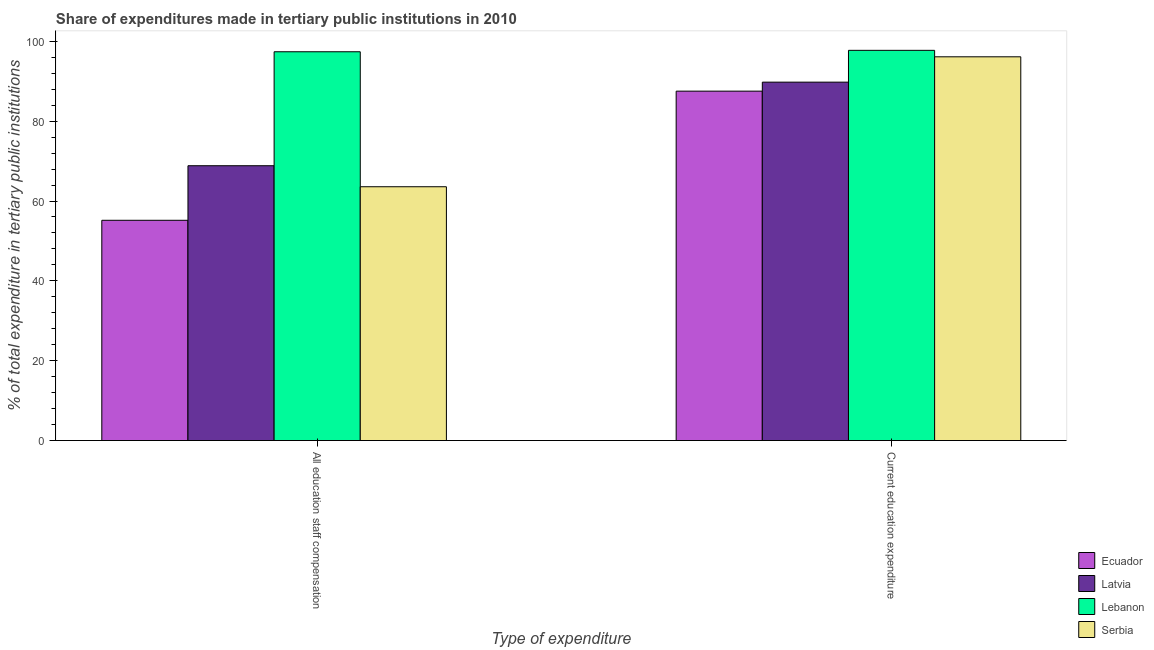How many different coloured bars are there?
Give a very brief answer. 4. How many groups of bars are there?
Your answer should be very brief. 2. How many bars are there on the 2nd tick from the left?
Give a very brief answer. 4. How many bars are there on the 1st tick from the right?
Ensure brevity in your answer.  4. What is the label of the 1st group of bars from the left?
Provide a short and direct response. All education staff compensation. What is the expenditure in staff compensation in Latvia?
Provide a succinct answer. 68.84. Across all countries, what is the maximum expenditure in staff compensation?
Your answer should be compact. 97.38. Across all countries, what is the minimum expenditure in education?
Your response must be concise. 87.52. In which country was the expenditure in staff compensation maximum?
Offer a very short reply. Lebanon. In which country was the expenditure in education minimum?
Keep it short and to the point. Ecuador. What is the total expenditure in staff compensation in the graph?
Your answer should be very brief. 284.96. What is the difference between the expenditure in education in Serbia and that in Lebanon?
Make the answer very short. -1.62. What is the difference between the expenditure in staff compensation in Lebanon and the expenditure in education in Ecuador?
Your answer should be very brief. 9.86. What is the average expenditure in education per country?
Offer a very short reply. 92.78. What is the difference between the expenditure in education and expenditure in staff compensation in Latvia?
Your response must be concise. 20.93. What is the ratio of the expenditure in staff compensation in Lebanon to that in Latvia?
Provide a short and direct response. 1.41. In how many countries, is the expenditure in staff compensation greater than the average expenditure in staff compensation taken over all countries?
Your answer should be very brief. 1. What does the 4th bar from the left in Current education expenditure represents?
Your answer should be very brief. Serbia. What does the 2nd bar from the right in Current education expenditure represents?
Your response must be concise. Lebanon. How many bars are there?
Provide a succinct answer. 8. Are all the bars in the graph horizontal?
Keep it short and to the point. No. What is the title of the graph?
Ensure brevity in your answer.  Share of expenditures made in tertiary public institutions in 2010. What is the label or title of the X-axis?
Provide a succinct answer. Type of expenditure. What is the label or title of the Y-axis?
Your answer should be compact. % of total expenditure in tertiary public institutions. What is the % of total expenditure in tertiary public institutions of Ecuador in All education staff compensation?
Ensure brevity in your answer.  55.17. What is the % of total expenditure in tertiary public institutions in Latvia in All education staff compensation?
Your answer should be compact. 68.84. What is the % of total expenditure in tertiary public institutions in Lebanon in All education staff compensation?
Offer a terse response. 97.38. What is the % of total expenditure in tertiary public institutions of Serbia in All education staff compensation?
Make the answer very short. 63.57. What is the % of total expenditure in tertiary public institutions of Ecuador in Current education expenditure?
Provide a succinct answer. 87.52. What is the % of total expenditure in tertiary public institutions in Latvia in Current education expenditure?
Your answer should be very brief. 89.77. What is the % of total expenditure in tertiary public institutions in Lebanon in Current education expenditure?
Give a very brief answer. 97.74. What is the % of total expenditure in tertiary public institutions in Serbia in Current education expenditure?
Offer a very short reply. 96.12. Across all Type of expenditure, what is the maximum % of total expenditure in tertiary public institutions of Ecuador?
Your answer should be very brief. 87.52. Across all Type of expenditure, what is the maximum % of total expenditure in tertiary public institutions in Latvia?
Make the answer very short. 89.77. Across all Type of expenditure, what is the maximum % of total expenditure in tertiary public institutions of Lebanon?
Make the answer very short. 97.74. Across all Type of expenditure, what is the maximum % of total expenditure in tertiary public institutions of Serbia?
Make the answer very short. 96.12. Across all Type of expenditure, what is the minimum % of total expenditure in tertiary public institutions of Ecuador?
Provide a succinct answer. 55.17. Across all Type of expenditure, what is the minimum % of total expenditure in tertiary public institutions in Latvia?
Offer a terse response. 68.84. Across all Type of expenditure, what is the minimum % of total expenditure in tertiary public institutions in Lebanon?
Make the answer very short. 97.38. Across all Type of expenditure, what is the minimum % of total expenditure in tertiary public institutions of Serbia?
Make the answer very short. 63.57. What is the total % of total expenditure in tertiary public institutions in Ecuador in the graph?
Give a very brief answer. 142.69. What is the total % of total expenditure in tertiary public institutions in Latvia in the graph?
Your answer should be very brief. 158.61. What is the total % of total expenditure in tertiary public institutions in Lebanon in the graph?
Offer a terse response. 195.12. What is the total % of total expenditure in tertiary public institutions in Serbia in the graph?
Ensure brevity in your answer.  159.69. What is the difference between the % of total expenditure in tertiary public institutions in Ecuador in All education staff compensation and that in Current education expenditure?
Your answer should be compact. -32.34. What is the difference between the % of total expenditure in tertiary public institutions of Latvia in All education staff compensation and that in Current education expenditure?
Offer a terse response. -20.93. What is the difference between the % of total expenditure in tertiary public institutions of Lebanon in All education staff compensation and that in Current education expenditure?
Ensure brevity in your answer.  -0.36. What is the difference between the % of total expenditure in tertiary public institutions of Serbia in All education staff compensation and that in Current education expenditure?
Give a very brief answer. -32.54. What is the difference between the % of total expenditure in tertiary public institutions in Ecuador in All education staff compensation and the % of total expenditure in tertiary public institutions in Latvia in Current education expenditure?
Offer a terse response. -34.6. What is the difference between the % of total expenditure in tertiary public institutions in Ecuador in All education staff compensation and the % of total expenditure in tertiary public institutions in Lebanon in Current education expenditure?
Provide a short and direct response. -42.56. What is the difference between the % of total expenditure in tertiary public institutions of Ecuador in All education staff compensation and the % of total expenditure in tertiary public institutions of Serbia in Current education expenditure?
Offer a terse response. -40.94. What is the difference between the % of total expenditure in tertiary public institutions in Latvia in All education staff compensation and the % of total expenditure in tertiary public institutions in Lebanon in Current education expenditure?
Ensure brevity in your answer.  -28.9. What is the difference between the % of total expenditure in tertiary public institutions of Latvia in All education staff compensation and the % of total expenditure in tertiary public institutions of Serbia in Current education expenditure?
Provide a short and direct response. -27.28. What is the difference between the % of total expenditure in tertiary public institutions in Lebanon in All education staff compensation and the % of total expenditure in tertiary public institutions in Serbia in Current education expenditure?
Make the answer very short. 1.26. What is the average % of total expenditure in tertiary public institutions in Ecuador per Type of expenditure?
Offer a terse response. 71.34. What is the average % of total expenditure in tertiary public institutions of Latvia per Type of expenditure?
Offer a very short reply. 79.3. What is the average % of total expenditure in tertiary public institutions in Lebanon per Type of expenditure?
Your answer should be very brief. 97.56. What is the average % of total expenditure in tertiary public institutions of Serbia per Type of expenditure?
Make the answer very short. 79.84. What is the difference between the % of total expenditure in tertiary public institutions of Ecuador and % of total expenditure in tertiary public institutions of Latvia in All education staff compensation?
Your answer should be compact. -13.66. What is the difference between the % of total expenditure in tertiary public institutions of Ecuador and % of total expenditure in tertiary public institutions of Lebanon in All education staff compensation?
Make the answer very short. -42.21. What is the difference between the % of total expenditure in tertiary public institutions in Ecuador and % of total expenditure in tertiary public institutions in Serbia in All education staff compensation?
Provide a short and direct response. -8.4. What is the difference between the % of total expenditure in tertiary public institutions in Latvia and % of total expenditure in tertiary public institutions in Lebanon in All education staff compensation?
Ensure brevity in your answer.  -28.54. What is the difference between the % of total expenditure in tertiary public institutions of Latvia and % of total expenditure in tertiary public institutions of Serbia in All education staff compensation?
Provide a succinct answer. 5.26. What is the difference between the % of total expenditure in tertiary public institutions in Lebanon and % of total expenditure in tertiary public institutions in Serbia in All education staff compensation?
Make the answer very short. 33.81. What is the difference between the % of total expenditure in tertiary public institutions in Ecuador and % of total expenditure in tertiary public institutions in Latvia in Current education expenditure?
Provide a succinct answer. -2.25. What is the difference between the % of total expenditure in tertiary public institutions in Ecuador and % of total expenditure in tertiary public institutions in Lebanon in Current education expenditure?
Give a very brief answer. -10.22. What is the difference between the % of total expenditure in tertiary public institutions in Ecuador and % of total expenditure in tertiary public institutions in Serbia in Current education expenditure?
Make the answer very short. -8.6. What is the difference between the % of total expenditure in tertiary public institutions of Latvia and % of total expenditure in tertiary public institutions of Lebanon in Current education expenditure?
Keep it short and to the point. -7.97. What is the difference between the % of total expenditure in tertiary public institutions in Latvia and % of total expenditure in tertiary public institutions in Serbia in Current education expenditure?
Give a very brief answer. -6.35. What is the difference between the % of total expenditure in tertiary public institutions in Lebanon and % of total expenditure in tertiary public institutions in Serbia in Current education expenditure?
Provide a succinct answer. 1.62. What is the ratio of the % of total expenditure in tertiary public institutions in Ecuador in All education staff compensation to that in Current education expenditure?
Your response must be concise. 0.63. What is the ratio of the % of total expenditure in tertiary public institutions of Latvia in All education staff compensation to that in Current education expenditure?
Offer a terse response. 0.77. What is the ratio of the % of total expenditure in tertiary public institutions of Serbia in All education staff compensation to that in Current education expenditure?
Keep it short and to the point. 0.66. What is the difference between the highest and the second highest % of total expenditure in tertiary public institutions in Ecuador?
Your answer should be compact. 32.34. What is the difference between the highest and the second highest % of total expenditure in tertiary public institutions in Latvia?
Offer a terse response. 20.93. What is the difference between the highest and the second highest % of total expenditure in tertiary public institutions of Lebanon?
Make the answer very short. 0.36. What is the difference between the highest and the second highest % of total expenditure in tertiary public institutions of Serbia?
Give a very brief answer. 32.54. What is the difference between the highest and the lowest % of total expenditure in tertiary public institutions in Ecuador?
Ensure brevity in your answer.  32.34. What is the difference between the highest and the lowest % of total expenditure in tertiary public institutions of Latvia?
Make the answer very short. 20.93. What is the difference between the highest and the lowest % of total expenditure in tertiary public institutions of Lebanon?
Keep it short and to the point. 0.36. What is the difference between the highest and the lowest % of total expenditure in tertiary public institutions in Serbia?
Keep it short and to the point. 32.54. 